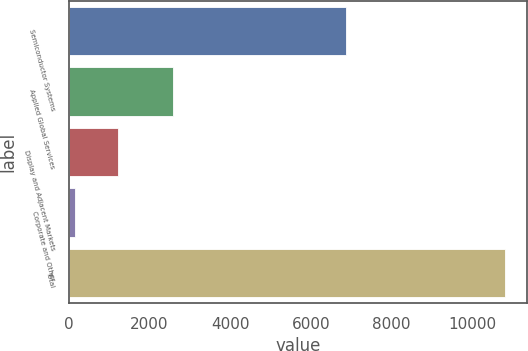<chart> <loc_0><loc_0><loc_500><loc_500><bar_chart><fcel>Semiconductor Systems<fcel>Applied Global Services<fcel>Display and Adjacent Markets<fcel>Corporate and Other<fcel>Total<nl><fcel>6873<fcel>2589<fcel>1223.8<fcel>157<fcel>10825<nl></chart> 